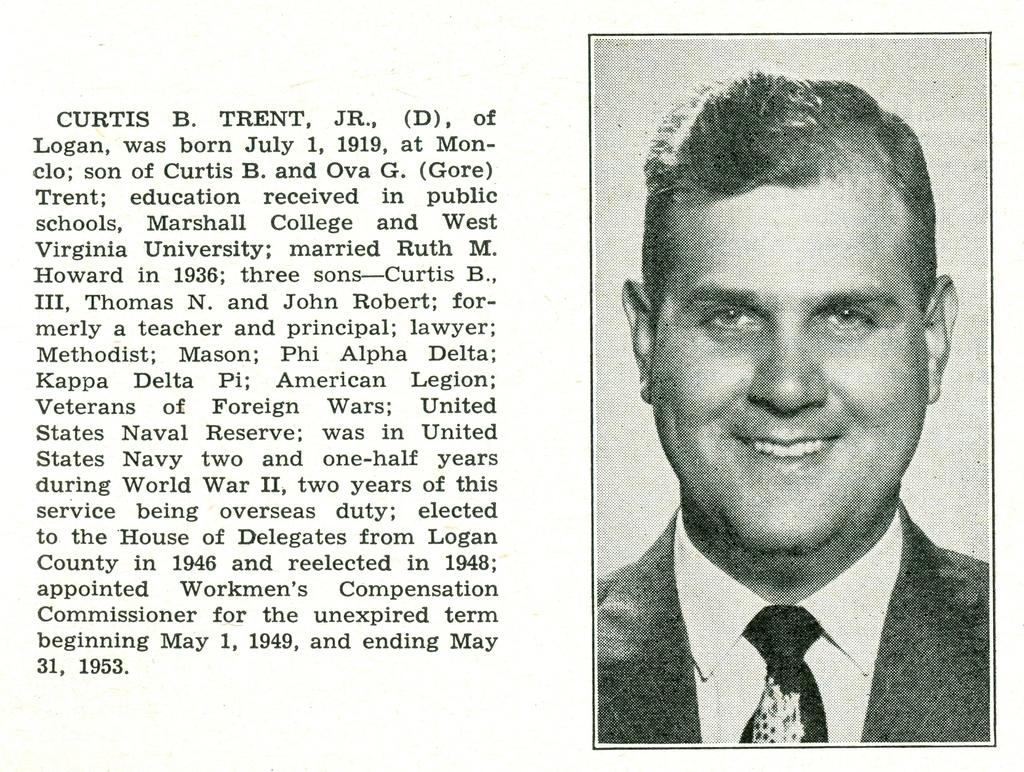What is the color scheme of the poster in the image? The poster is black and white. What is depicted on the poster? The poster features a man. Where is the text located on the poster? The text is on the left side of the poster. How many geese are part of the flock depicted on the poster? There are no geese or flock depicted on the poster; it features a man. What belief system is represented by the man on the poster? The image does not provide enough information to determine any belief system represented by the man on the poster. 